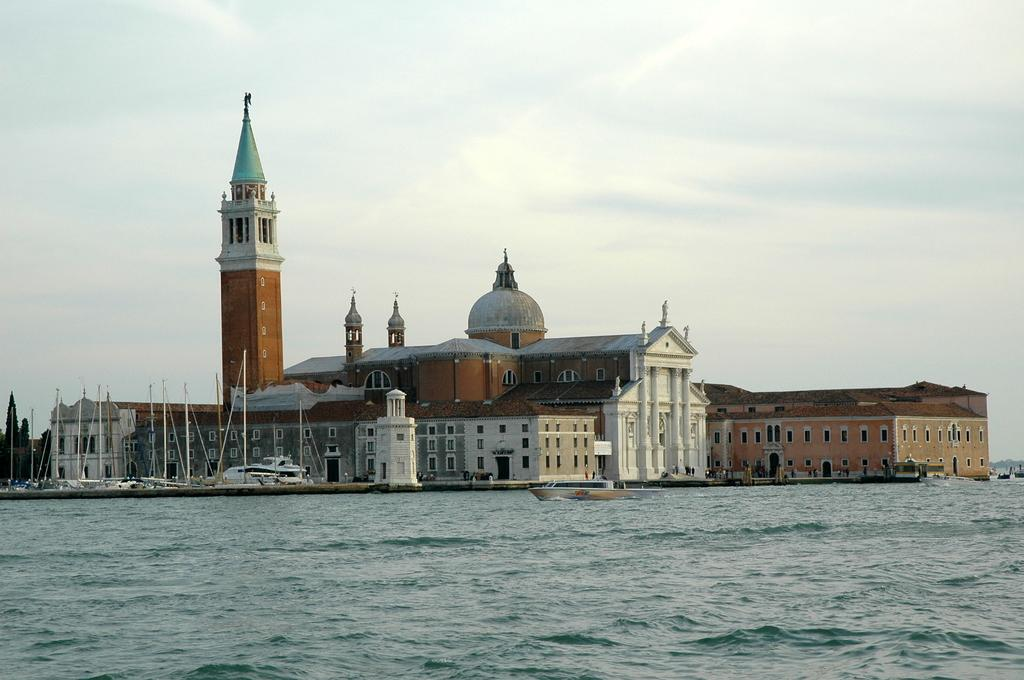What is located at the bottom of the image? There is water at the bottom of the image. What can be seen in the middle of the image? There are boats and buildings in the middle of the image. What is visible at the top of the image? The sky is visible at the top of the image. What type of plant is growing on the chain in the image? There is no plant or chain present in the image. What nation is depicted in the image? The image does not depict any specific nation; it features water, boats, buildings, and the sky. 